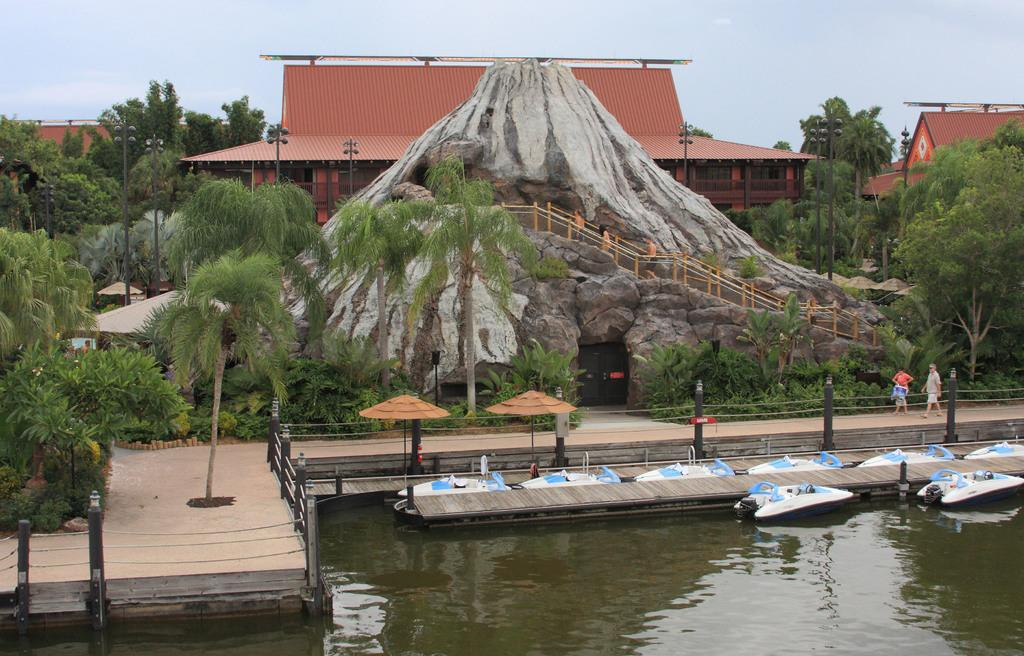What is on the water in the image? There are boats on the water in the image. Where are the two persons located in the image? The two persons are standing in the right corner of the image. What can be seen in the background of the image? There is a mountain, trees, poles, and buildings in the background of the image. What type of banana is hanging from the trees in the background of the image? There are no bananas visible in the image; only trees are present in the background. Can you tell me how many hearts are visible in the image? There are no hearts present in the image. 